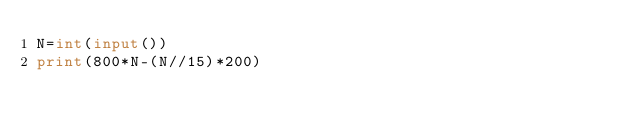Convert code to text. <code><loc_0><loc_0><loc_500><loc_500><_Python_>N=int(input())
print(800*N-(N//15)*200)</code> 